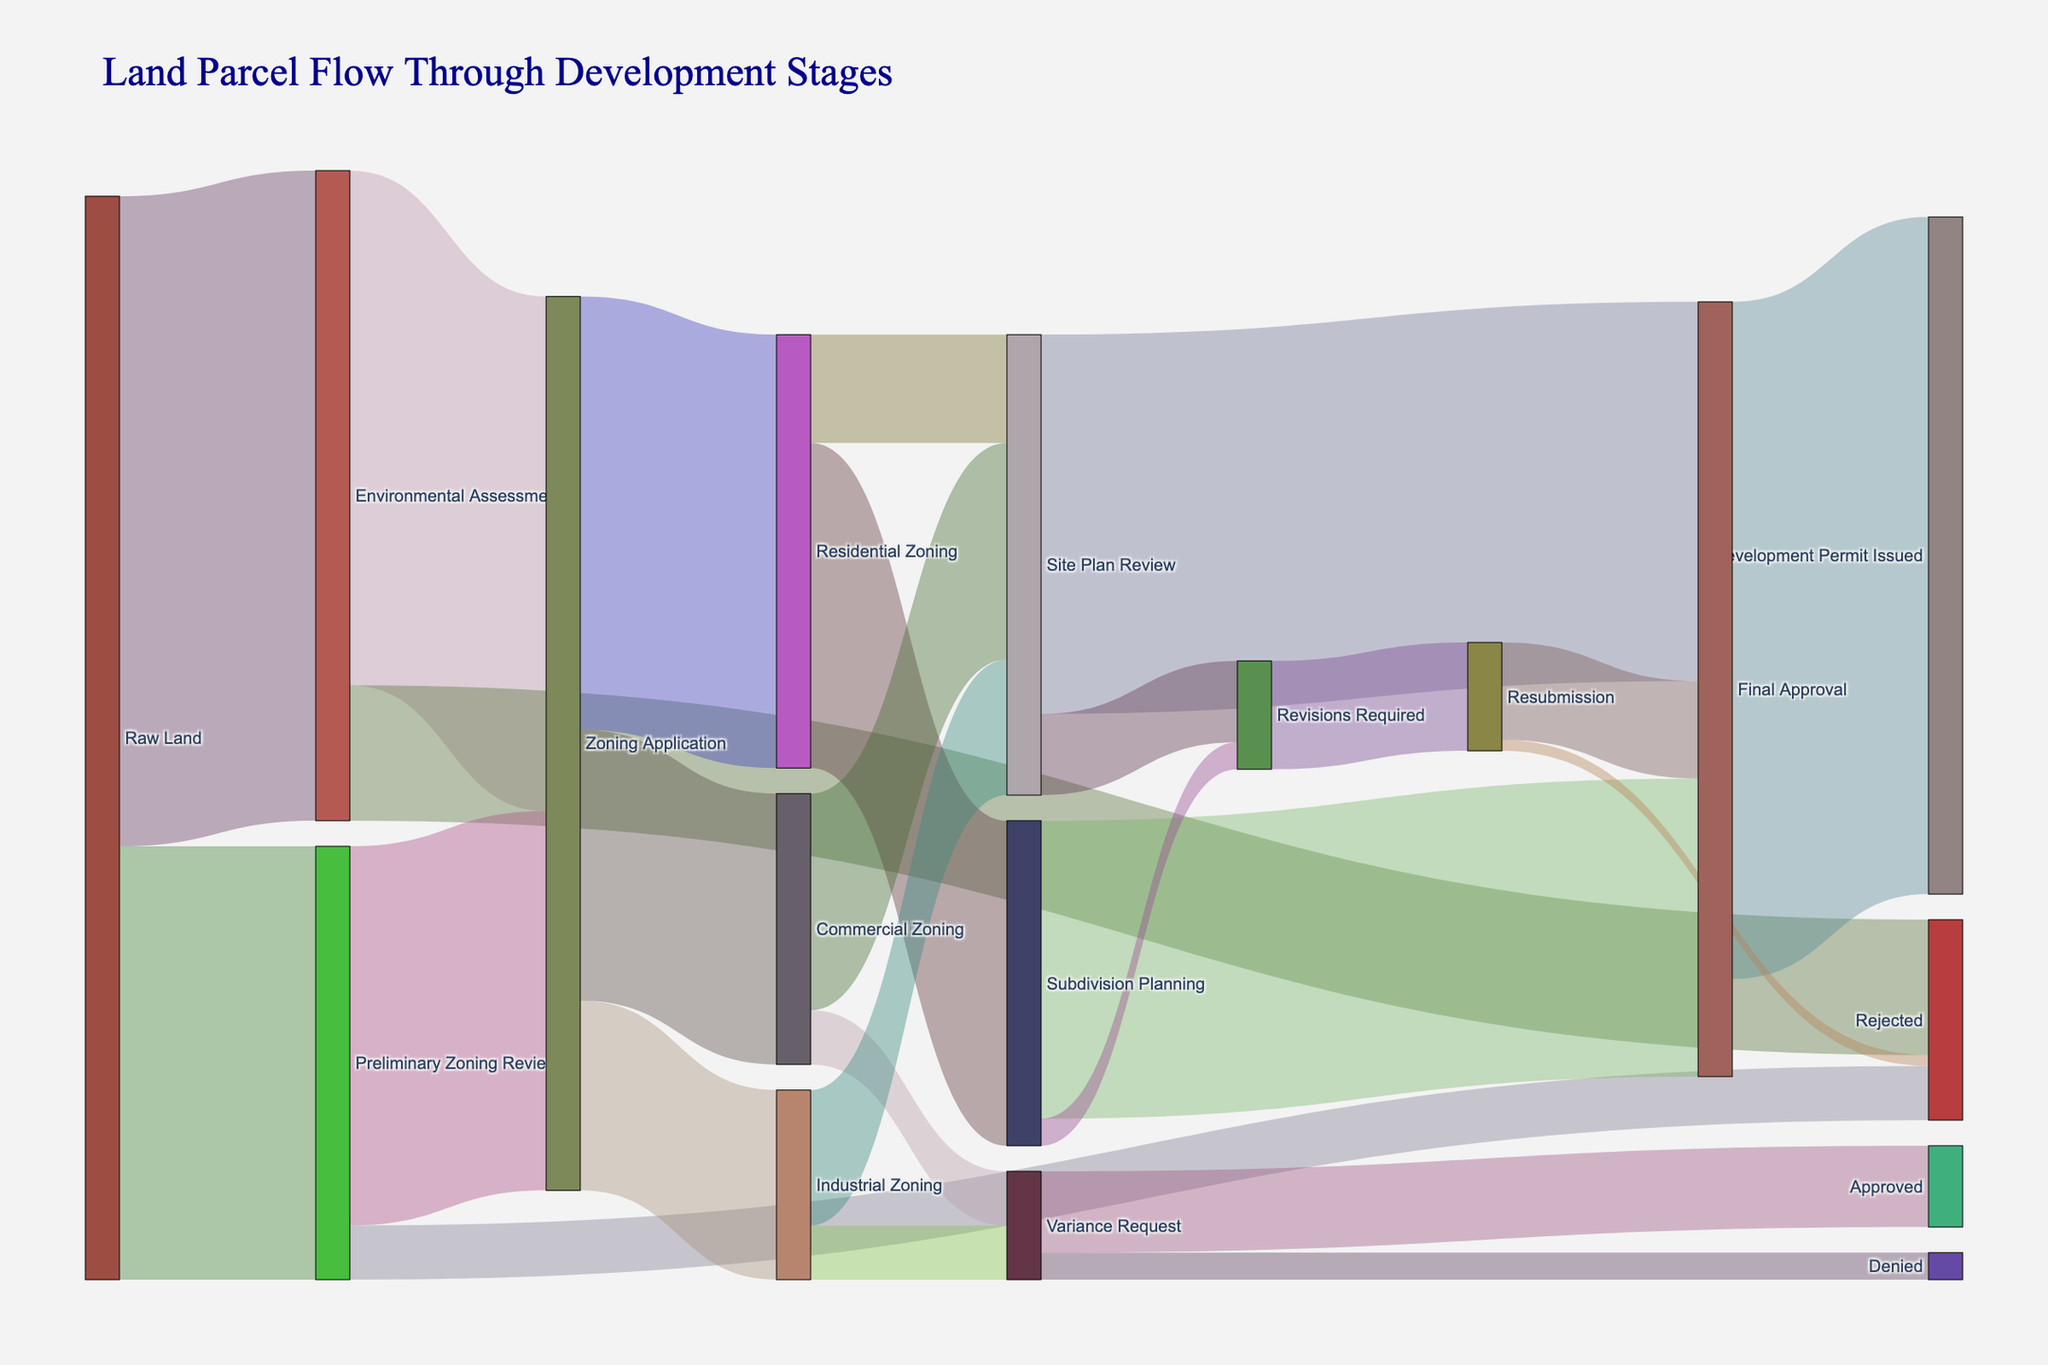How many land parcels go through the Environmental Assessment stage? From the figure, the flow from Raw Land to Environmental Assessment is represented by a link with a value of 1200 parcels.
Answer: 1200 What is the total number of land parcels that are rejected at any stage? Adding the values of parcels rejected at different stages: Environmental Assessment to Rejected (250), Preliminary Zoning Review to Rejected (100), and Resubmission to Rejected (20). The total is 250 + 100 + 20 = 370.
Answer: 370 How many parcels proceed from Subdivision Planning to Final Approval? The figure indicates a flow from Subdivision Planning to Final Approval with a value of 550 parcels.
Answer: 550 Compare the number of parcels that go from Zoning Application to Residential Zoning and Commercial Zoning. Which one is higher and by how much? The figure shows 800 parcels moving to Residential Zoning and 500 parcels to Commercial Zoning. The difference is 800 - 500 = 300, so Residential Zoning has 300 more parcels.
Answer: Residential Zoning, 300 more What is the percentage of raw land parcels that reach the final "Development Permit Issued" stage? The total number of raw land parcels is 1200 + 800 = 2000. The number of parcels reaching Development Permit Issued is 1250. The percentage is (1250 / 2000) * 100 = 62.5%.
Answer: 62.5% What is the final number of parcels that receive site plan reviews? Summing up all parcels that reach "Site Plan Review": 200 (Residential Zoning) + 400 (Commercial Zoning) + 250 (Industrial Zoning) = 850.
Answer: 850 Which stage has the highest number of parcels entering it, and how many parcels does it have? The Environmental Assessment stage has the highest inflow with 1200 parcels proceeding to it from Raw Land.
Answer: Environmental Assessment, 1200 What is the total flow of parcels from the Zoning Application to all subsequent stages? Summing up the parcels from Zoning Application to its targets: 800 (Residential Zoning) + 500 (Commercial Zoning) + 350 (Industrial Zoning) = 1650.
Answer: 1650 How many parcels require revisions at any stage? Adding parcels needing revisions: Subdivision Planning to Revisions Required (50) and Site Plan Review to Revisions Required (150). The total is 50 + 150 = 200.
Answer: 200 How many parcels eventually get the final approval after being resubmitted? From Resubmission to Final Approval, the figure indicates 180 parcels.
Answer: 180 